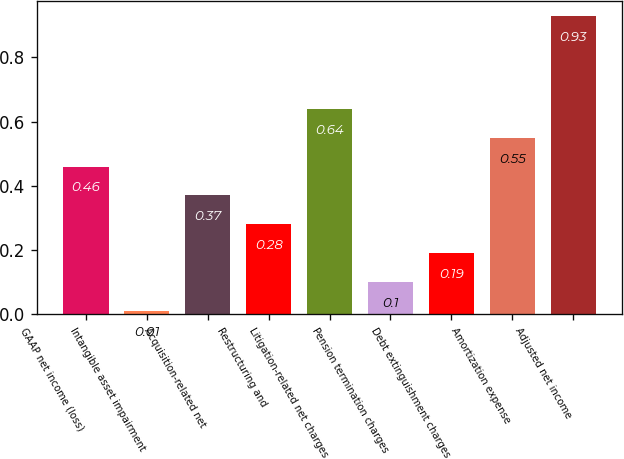<chart> <loc_0><loc_0><loc_500><loc_500><bar_chart><fcel>GAAP net income (loss)<fcel>Intangible asset impairment<fcel>Acquisition-related net<fcel>Restructuring and<fcel>Litigation-related net charges<fcel>Pension termination charges<fcel>Debt extinguishment charges<fcel>Amortization expense<fcel>Adjusted net income<nl><fcel>0.46<fcel>0.01<fcel>0.37<fcel>0.28<fcel>0.64<fcel>0.1<fcel>0.19<fcel>0.55<fcel>0.93<nl></chart> 